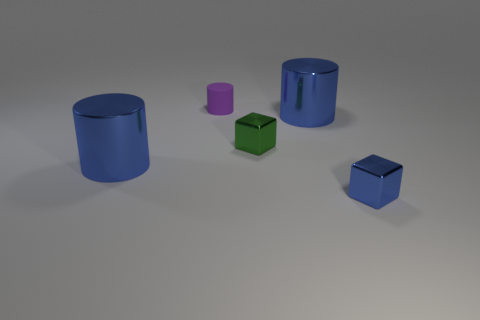Add 1 purple matte objects. How many objects exist? 6 Subtract all cubes. How many objects are left? 3 Subtract 0 purple blocks. How many objects are left? 5 Subtract all red cylinders. Subtract all small purple rubber things. How many objects are left? 4 Add 1 blue shiny cubes. How many blue shiny cubes are left? 2 Add 4 blue metal blocks. How many blue metal blocks exist? 5 